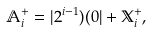Convert formula to latex. <formula><loc_0><loc_0><loc_500><loc_500>\mathbb { A } _ { i } ^ { + } = | 2 ^ { i - 1 } ) ( 0 | + \mathbb { X } _ { i } ^ { + } ,</formula> 